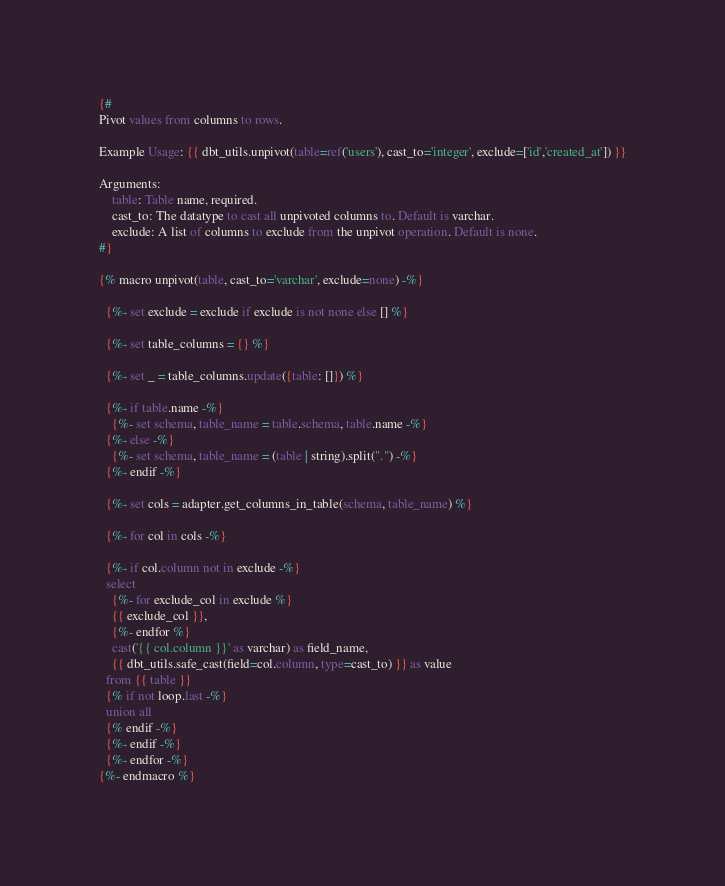Convert code to text. <code><loc_0><loc_0><loc_500><loc_500><_SQL_>{#
Pivot values from columns to rows.

Example Usage: {{ dbt_utils.unpivot(table=ref('users'), cast_to='integer', exclude=['id','created_at']) }}

Arguments:
    table: Table name, required.
    cast_to: The datatype to cast all unpivoted columns to. Default is varchar.
    exclude: A list of columns to exclude from the unpivot operation. Default is none.
#}

{% macro unpivot(table, cast_to='varchar', exclude=none) -%}

  {%- set exclude = exclude if exclude is not none else [] %}

  {%- set table_columns = {} %}

  {%- set _ = table_columns.update({table: []}) %}

  {%- if table.name -%}
    {%- set schema, table_name = table.schema, table.name -%}
  {%- else -%}
    {%- set schema, table_name = (table | string).split(".") -%}
  {%- endif -%}

  {%- set cols = adapter.get_columns_in_table(schema, table_name) %}

  {%- for col in cols -%}

  {%- if col.column not in exclude -%}
  select
    {%- for exclude_col in exclude %}
    {{ exclude_col }},
    {%- endfor %}
    cast('{{ col.column }}' as varchar) as field_name,
    {{ dbt_utils.safe_cast(field=col.column, type=cast_to) }} as value
  from {{ table }}
  {% if not loop.last -%}
  union all
  {% endif -%}
  {%- endif -%}
  {%- endfor -%}
{%- endmacro %}
</code> 